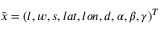<formula> <loc_0><loc_0><loc_500><loc_500>\tilde { x } = ( l , w , s , l a t , l o n , d , \alpha , \beta , \gamma ) ^ { T }</formula> 